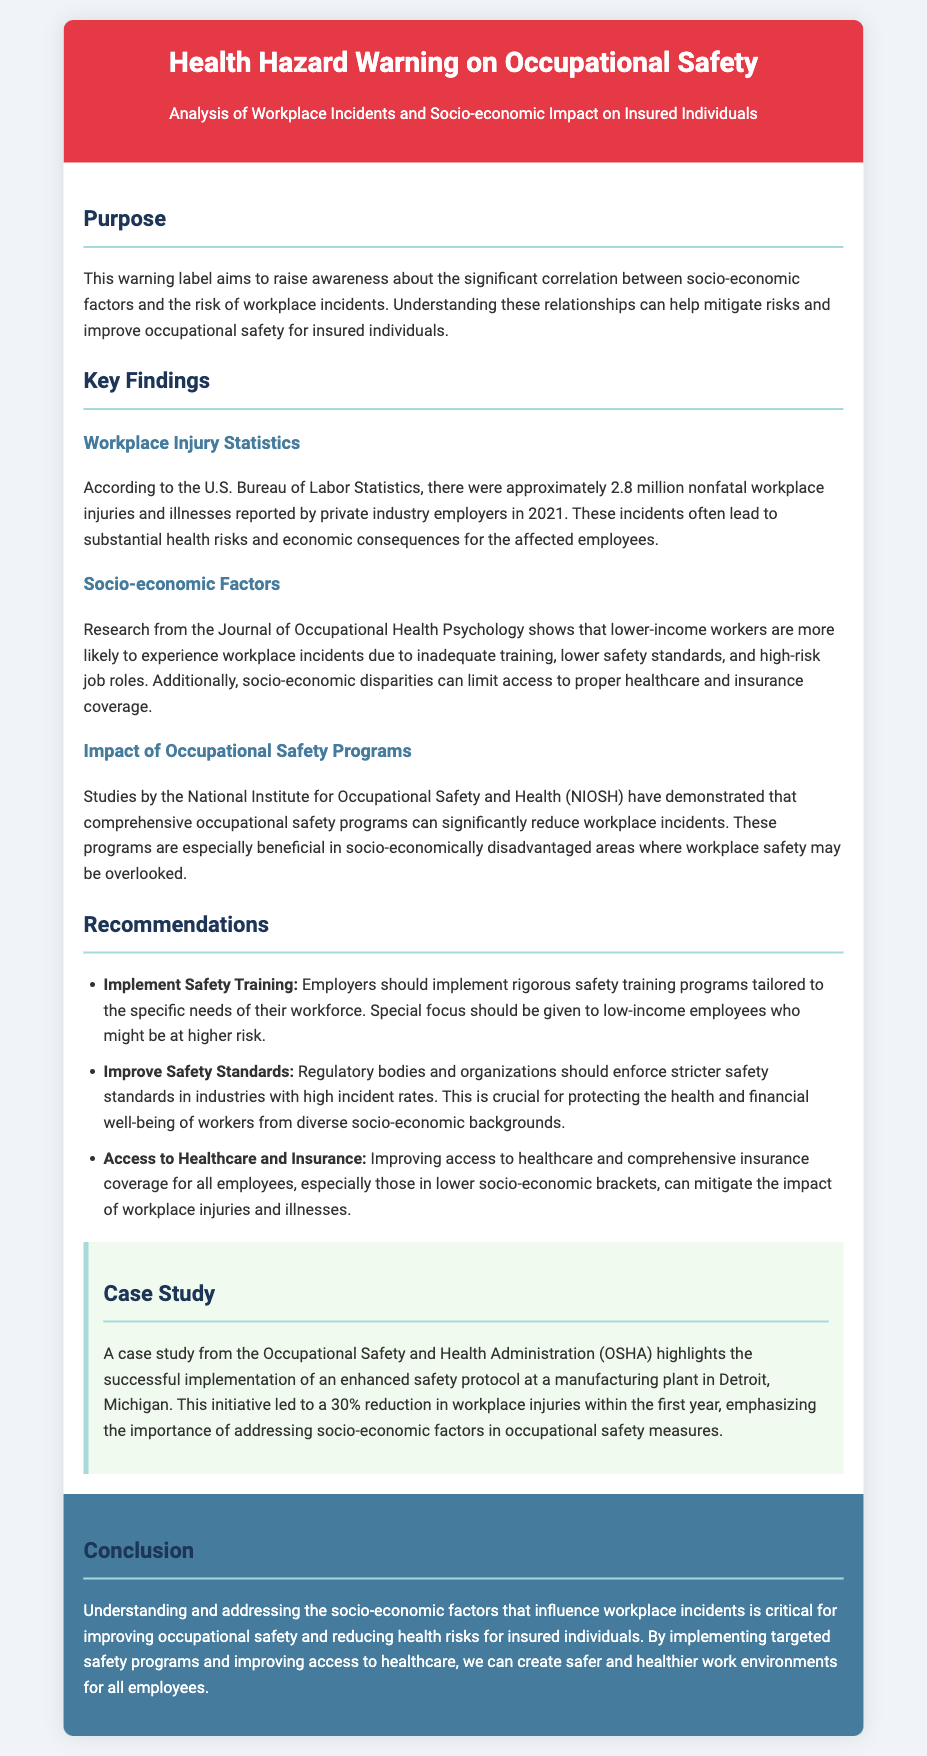What is the purpose of the warning label? The purpose of the warning label is to raise awareness about the significant correlation between socio-economic factors and the risk of workplace incidents.
Answer: Raise awareness about socio-economic factors and workplace incidents How many nonfatal workplace injuries were reported in 2021? Approximately 2.8 million nonfatal workplace injuries were reported by private industry employers in 2021.
Answer: 2.8 million Which socio-economic group is more likely to experience workplace incidents? Lower-income workers are more likely to experience workplace incidents.
Answer: Lower-income workers What does NIOSH stand for? NIOSH stands for the National Institute for Occupational Safety and Health.
Answer: National Institute for Occupational Safety and Health What percentage reduction in workplace injuries was observed in the case study? The case study reported a 30% reduction in workplace injuries within the first year.
Answer: 30% What is recommended to improve access to healthcare? Improving access to healthcare and comprehensive insurance coverage is recommended.
Answer: Comprehensive insurance coverage What is the main focus of safety training programs according to the recommendations? Employers should implement rigorous safety training programs tailored to the specific needs of their workforce.
Answer: Specific needs of their workforce What is the significance of the case study from OSHA? The case study highlights the successful implementation of an enhanced safety protocol leading to a reduction in workplace injuries.
Answer: Successful implementation of an enhanced safety protocol 